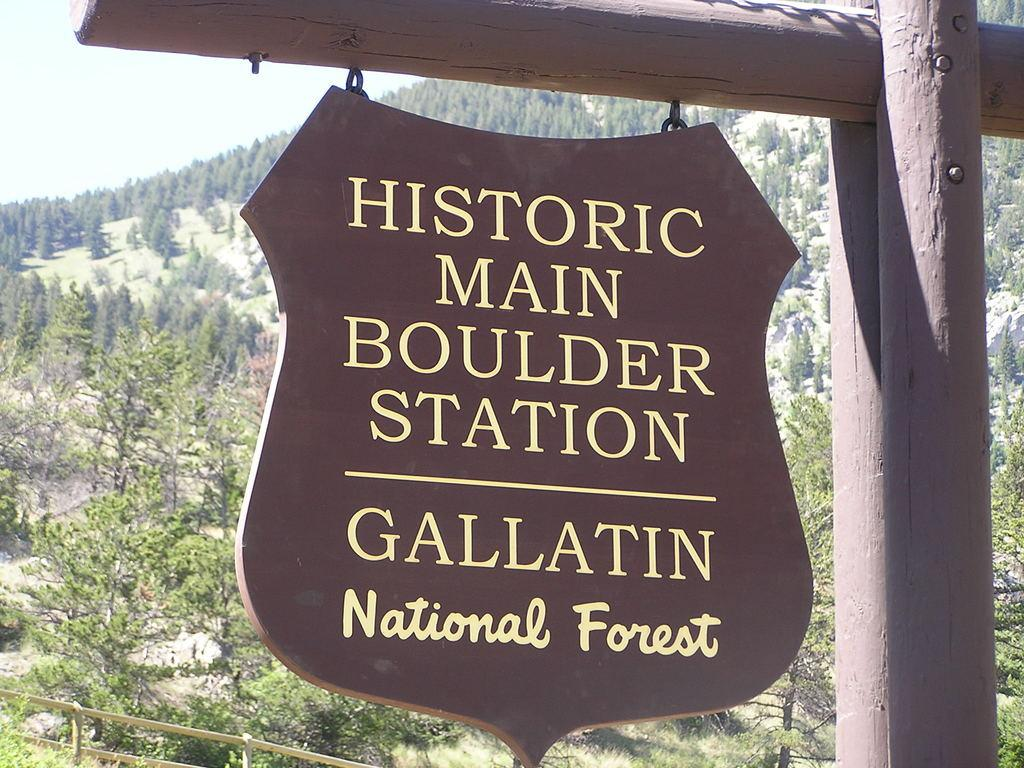What is the main object in the image? There is a wooden board in the image. How is the wooden board positioned? The wooden board is hanging from a wooden stick. What can be seen in the background of the image? There is a forest in the background of the image. What types of vegetation are present in the forest? The forest contains trees and plants. What other wooden object is visible in the image? There is a wooden pole on the right side of the image. What color is the skirt worn by the tree in the image? There is no tree wearing a skirt in the image; trees are not capable of wearing clothing. 